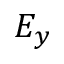<formula> <loc_0><loc_0><loc_500><loc_500>E _ { y }</formula> 